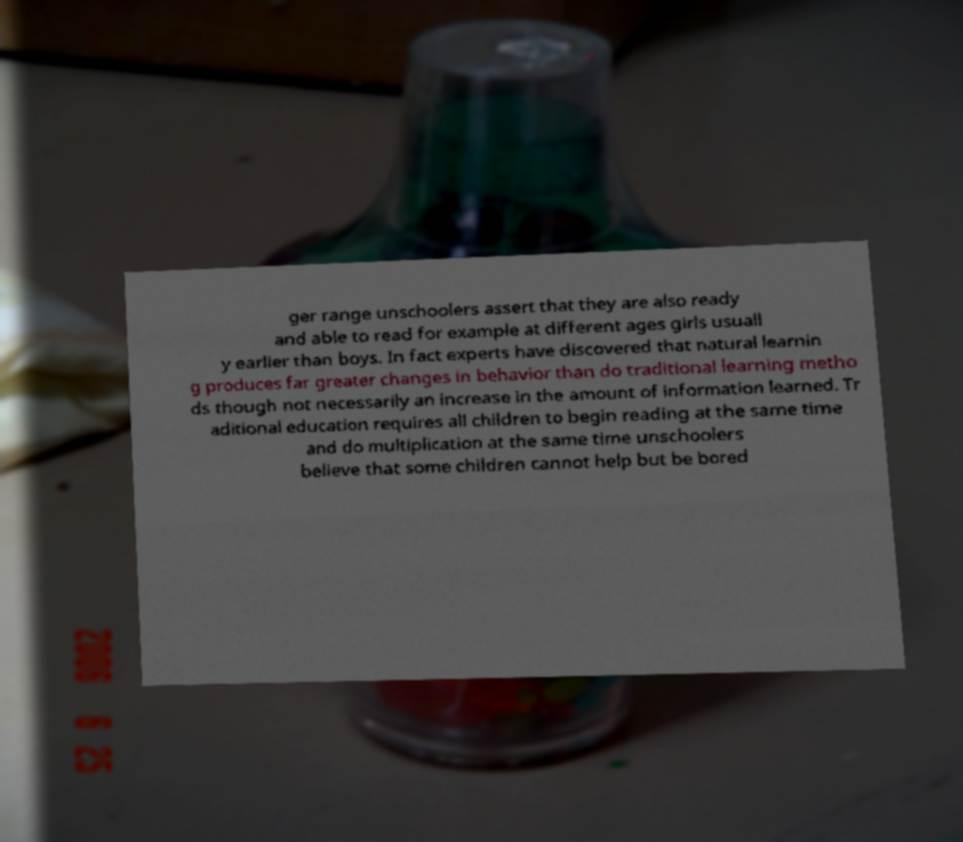There's text embedded in this image that I need extracted. Can you transcribe it verbatim? ger range unschoolers assert that they are also ready and able to read for example at different ages girls usuall y earlier than boys. In fact experts have discovered that natural learnin g produces far greater changes in behavior than do traditional learning metho ds though not necessarily an increase in the amount of information learned. Tr aditional education requires all children to begin reading at the same time and do multiplication at the same time unschoolers believe that some children cannot help but be bored 